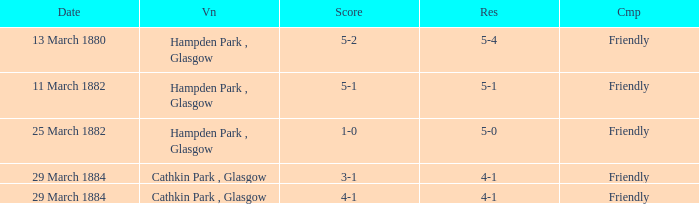Which item has a score of 5-1? 5-1. 